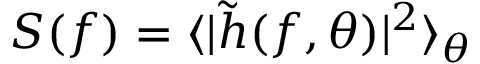Convert formula to latex. <formula><loc_0><loc_0><loc_500><loc_500>S ( f ) = \langle | \tilde { h } ( f , \theta ) | ^ { 2 } \rangle _ { \theta }</formula> 